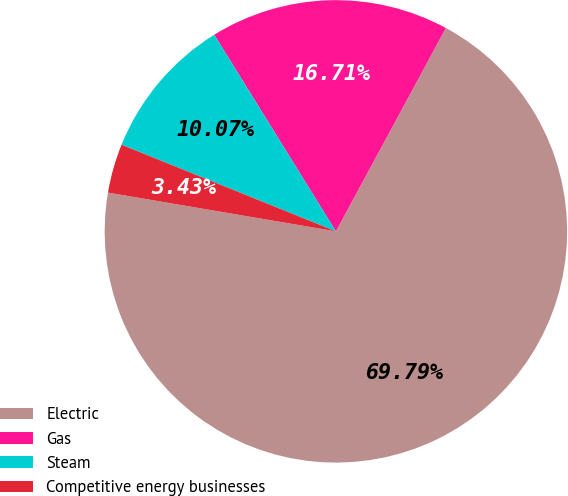<chart> <loc_0><loc_0><loc_500><loc_500><pie_chart><fcel>Electric<fcel>Gas<fcel>Steam<fcel>Competitive energy businesses<nl><fcel>69.79%<fcel>16.71%<fcel>10.07%<fcel>3.43%<nl></chart> 